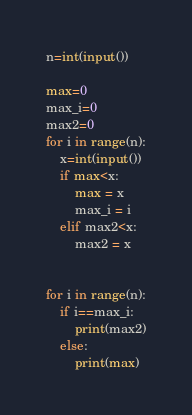Convert code to text. <code><loc_0><loc_0><loc_500><loc_500><_Python_>n=int(input())

max=0
max_i=0
max2=0
for i in range(n):
    x=int(input())
    if max<x:
        max = x
        max_i = i
    elif max2<x:
        max2 = x


for i in range(n):
    if i==max_i:
        print(max2)
    else:
        print(max)</code> 